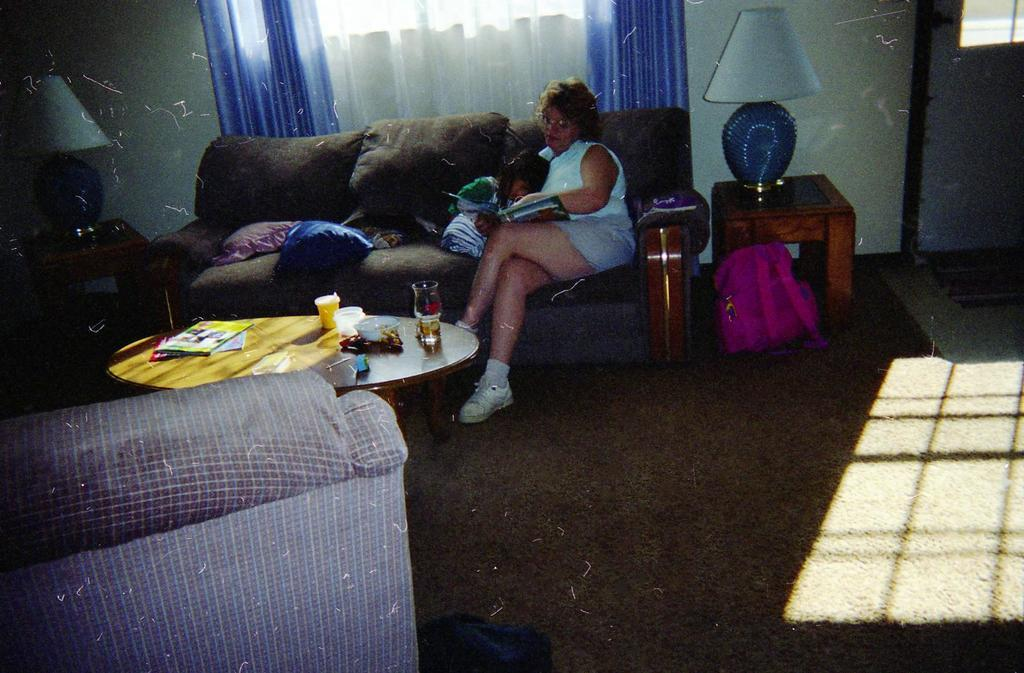What is the lady in the image doing? The lady is sitting on the sofa and holding a baby. What is the condition of the baby in the image? The baby is sleeping. What object is visible behind the lady? There is a lamp behind the lady. What type of window treatment is present in the image? There is a window with curtains hanging. What type of bird can be seen rolling flowers in the image? There is no bird or flowers present in the image; it features a lady sitting on a sofa holding a sleeping baby. 